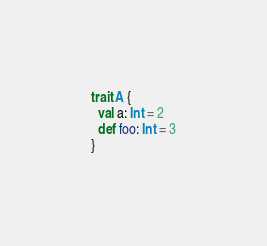Convert code to text. <code><loc_0><loc_0><loc_500><loc_500><_Scala_>trait A {
  val a: Int = 2
  def foo: Int = 3
}</code> 